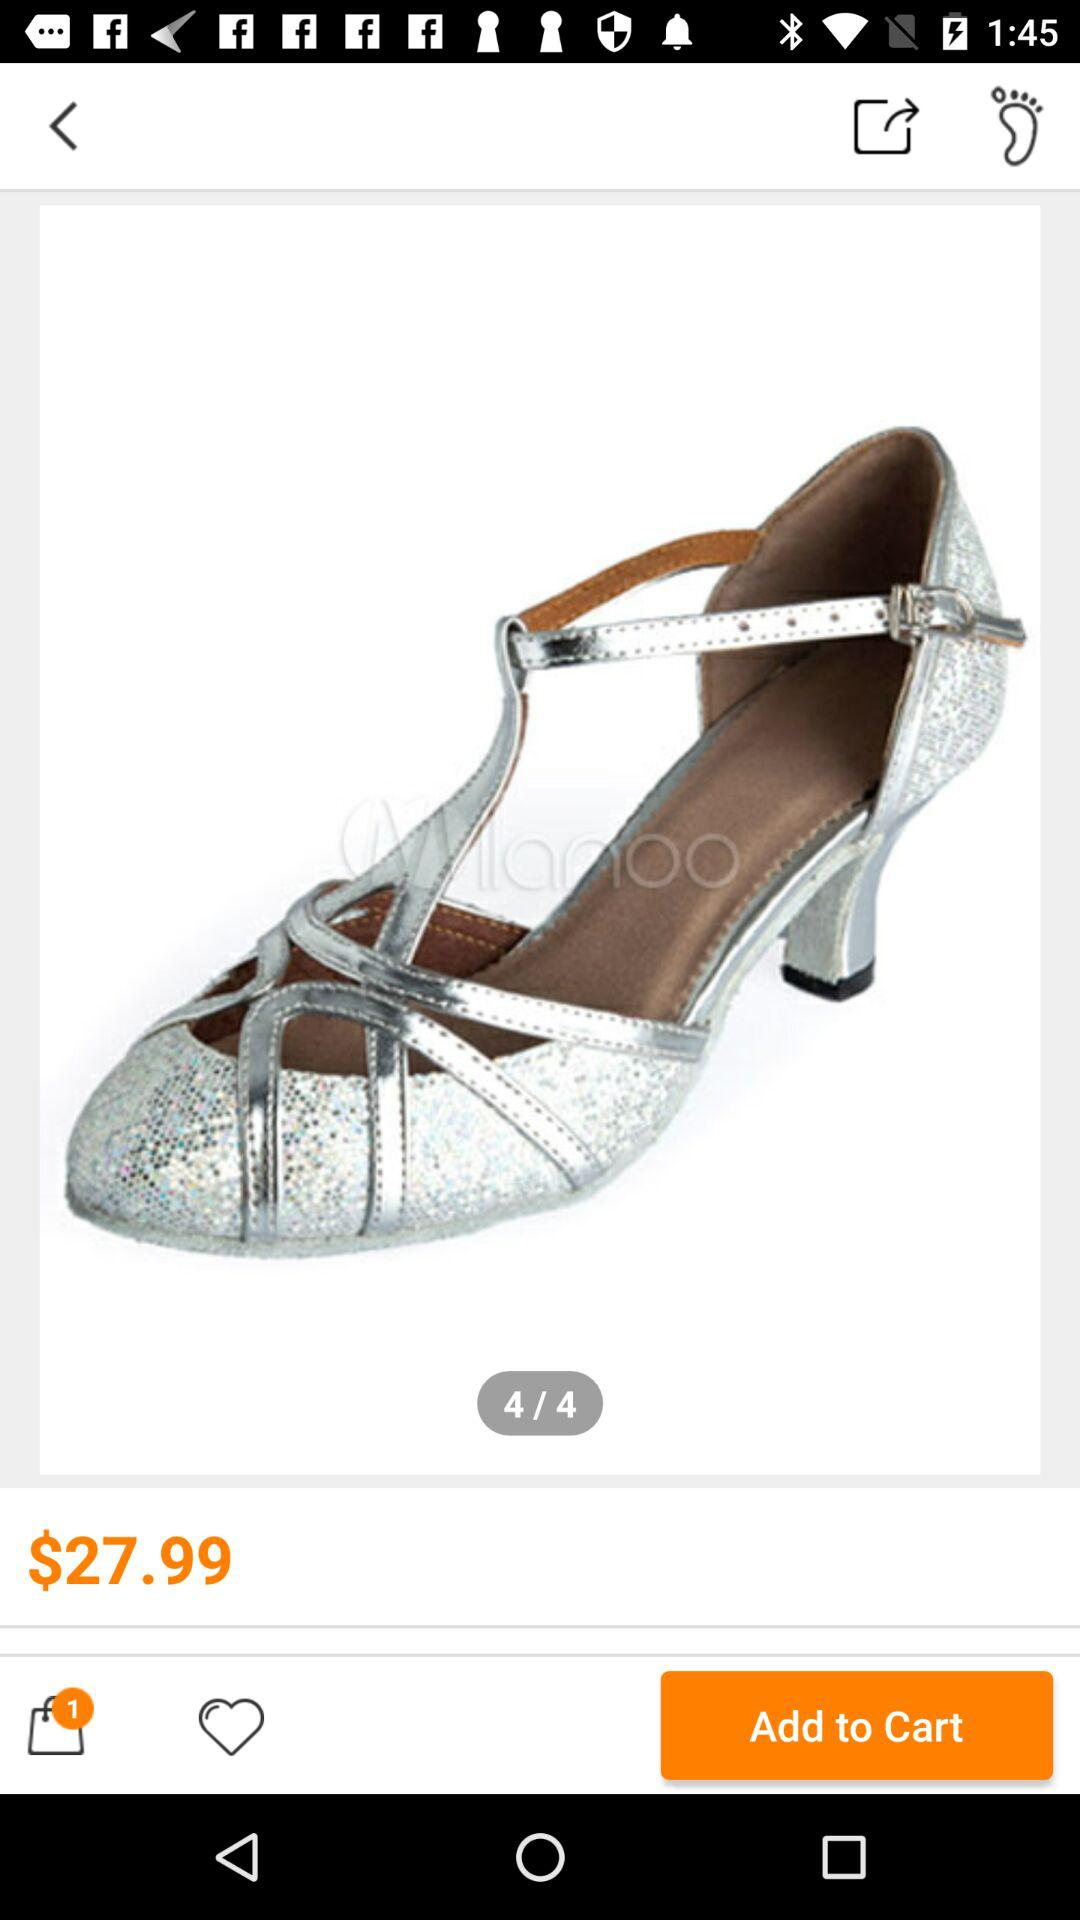How many products are added to the cart? The product added to the cart is 1. 